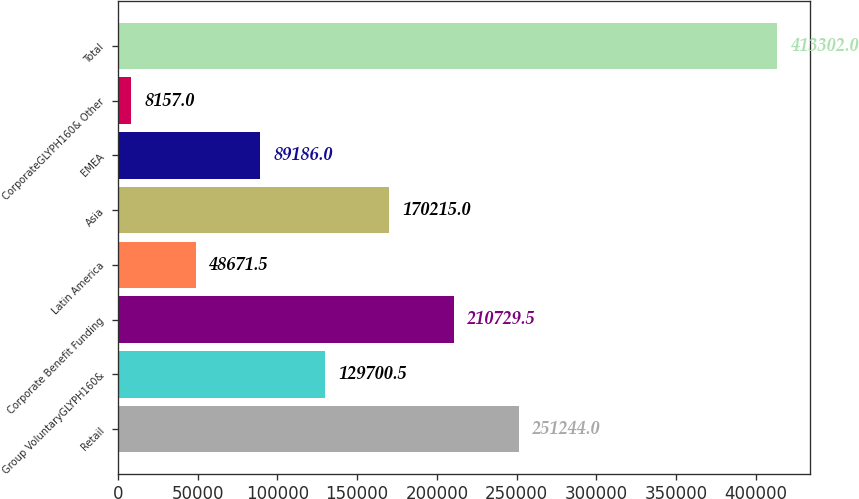Convert chart. <chart><loc_0><loc_0><loc_500><loc_500><bar_chart><fcel>Retail<fcel>Group VoluntaryGLYPH160&<fcel>Corporate Benefit Funding<fcel>Latin America<fcel>Asia<fcel>EMEA<fcel>CorporateGLYPH160& Other<fcel>Total<nl><fcel>251244<fcel>129700<fcel>210730<fcel>48671.5<fcel>170215<fcel>89186<fcel>8157<fcel>413302<nl></chart> 